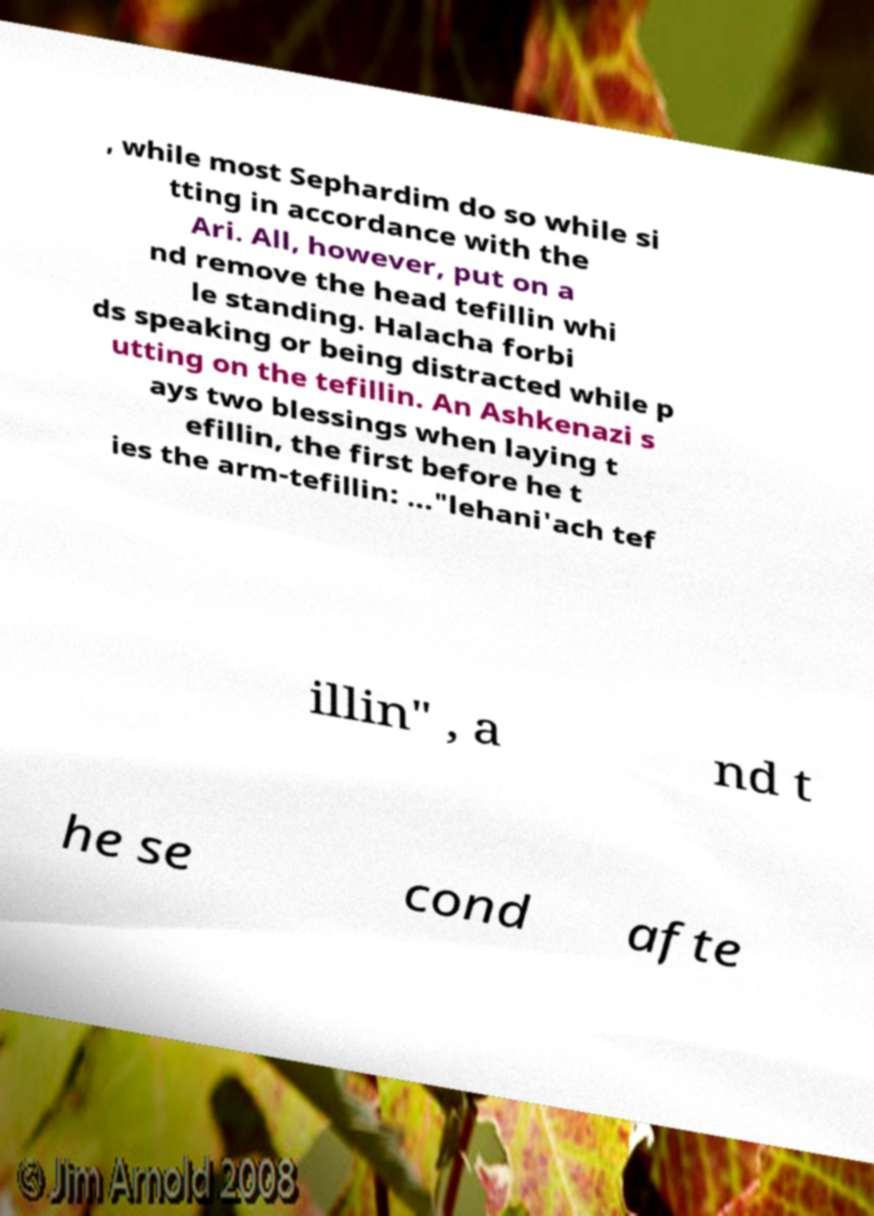For documentation purposes, I need the text within this image transcribed. Could you provide that? , while most Sephardim do so while si tting in accordance with the Ari. All, however, put on a nd remove the head tefillin whi le standing. Halacha forbi ds speaking or being distracted while p utting on the tefillin. An Ashkenazi s ays two blessings when laying t efillin, the first before he t ies the arm-tefillin: ..."lehani'ach tef illin" , a nd t he se cond afte 